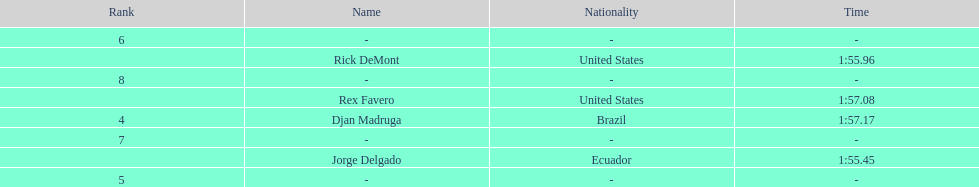What is the average time? 1:56.42. Could you parse the entire table? {'header': ['Rank', 'Name', 'Nationality', 'Time'], 'rows': [['6', '-', '-', '-'], ['', 'Rick DeMont', 'United States', '1:55.96'], ['8', '-', '-', '-'], ['', 'Rex Favero', 'United States', '1:57.08'], ['4', 'Djan Madruga', 'Brazil', '1:57.17'], ['7', '-', '-', '-'], ['', 'Jorge Delgado', 'Ecuador', '1:55.45'], ['5', '-', '-', '-']]} 